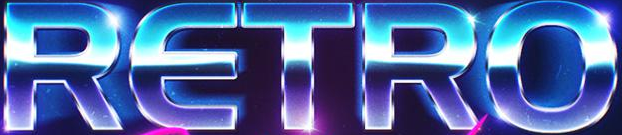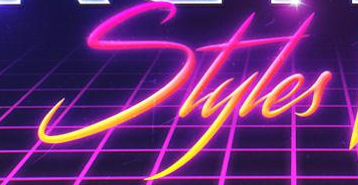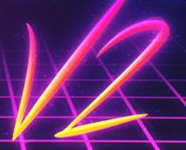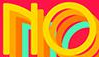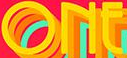Read the text content from these images in order, separated by a semicolon. RETRO; Styles; V2; NO; ONE 